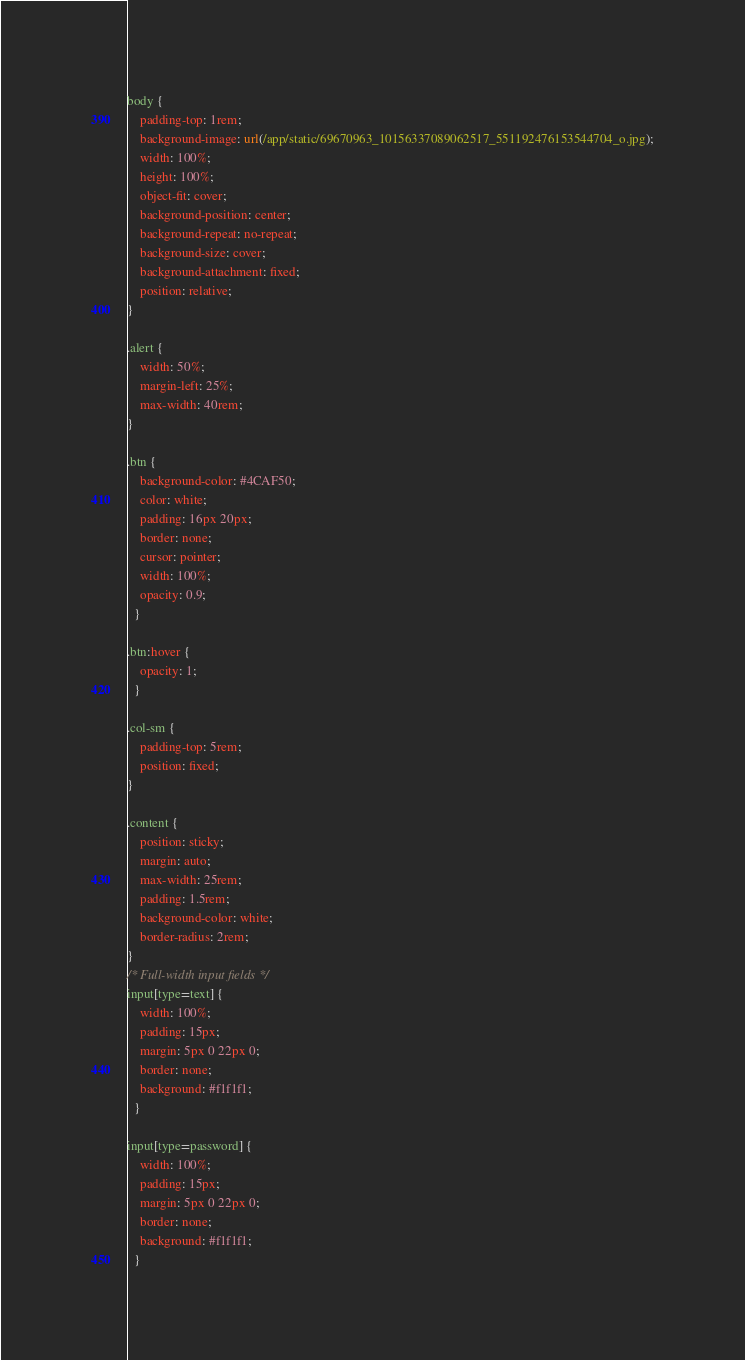<code> <loc_0><loc_0><loc_500><loc_500><_CSS_>body {
    padding-top: 1rem;
    background-image: url(/app/static/69670963_10156337089062517_551192476153544704_o.jpg);
    width: 100%;
    height: 100%;
    object-fit: cover;
    background-position: center;
    background-repeat: no-repeat;
    background-size: cover;
    background-attachment: fixed;
    position: relative;
}

.alert {
    width: 50%;
    margin-left: 25%;
    max-width: 40rem;
}

.btn {
    background-color: #4CAF50;
    color: white;
    padding: 16px 20px;
    border: none;
    cursor: pointer;
    width: 100%;
    opacity: 0.9;
  }
  
.btn:hover {
    opacity: 1;
  }

.col-sm {
    padding-top: 5rem;
    position: fixed;
}

.content {
    position: sticky;
    margin: auto;
    max-width: 25rem;
    padding: 1.5rem;
    background-color: white;
    border-radius: 2rem;
}
/* Full-width input fields */
input[type=text] {
    width: 100%;
    padding: 15px;
    margin: 5px 0 22px 0;
    border: none;
    background: #f1f1f1;
  }

input[type=password] {
    width: 100%;
    padding: 15px;
    margin: 5px 0 22px 0;
    border: none;
    background: #f1f1f1;
  }
</code> 